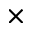<formula> <loc_0><loc_0><loc_500><loc_500>\times</formula> 